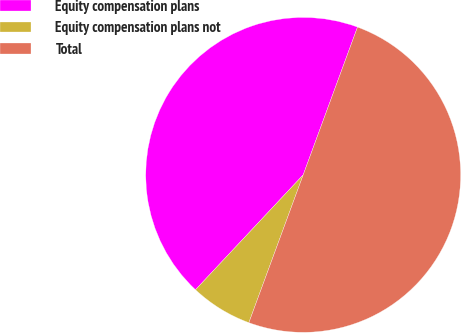Convert chart to OTSL. <chart><loc_0><loc_0><loc_500><loc_500><pie_chart><fcel>Equity compensation plans<fcel>Equity compensation plans not<fcel>Total<nl><fcel>43.62%<fcel>6.38%<fcel>50.0%<nl></chart> 